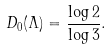Convert formula to latex. <formula><loc_0><loc_0><loc_500><loc_500>D _ { 0 } ( \Lambda ) = \frac { \log 2 } { \log 3 } .</formula> 